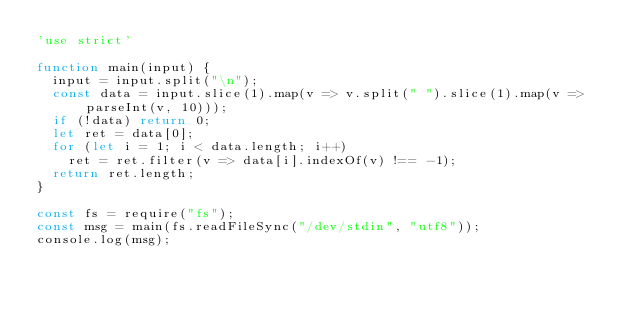Convert code to text. <code><loc_0><loc_0><loc_500><loc_500><_JavaScript_>'use strict'
 
function main(input) {
  input = input.split("\n");
  const data = input.slice(1).map(v => v.split(" ").slice(1).map(v => parseInt(v, 10)));
  if (!data) return 0;
  let ret = data[0];
  for (let i = 1; i < data.length; i++)
    ret = ret.filter(v => data[i].indexOf(v) !== -1);
  return ret.length;
}
 
const fs = require("fs");
const msg = main(fs.readFileSync("/dev/stdin", "utf8"));
console.log(msg);</code> 